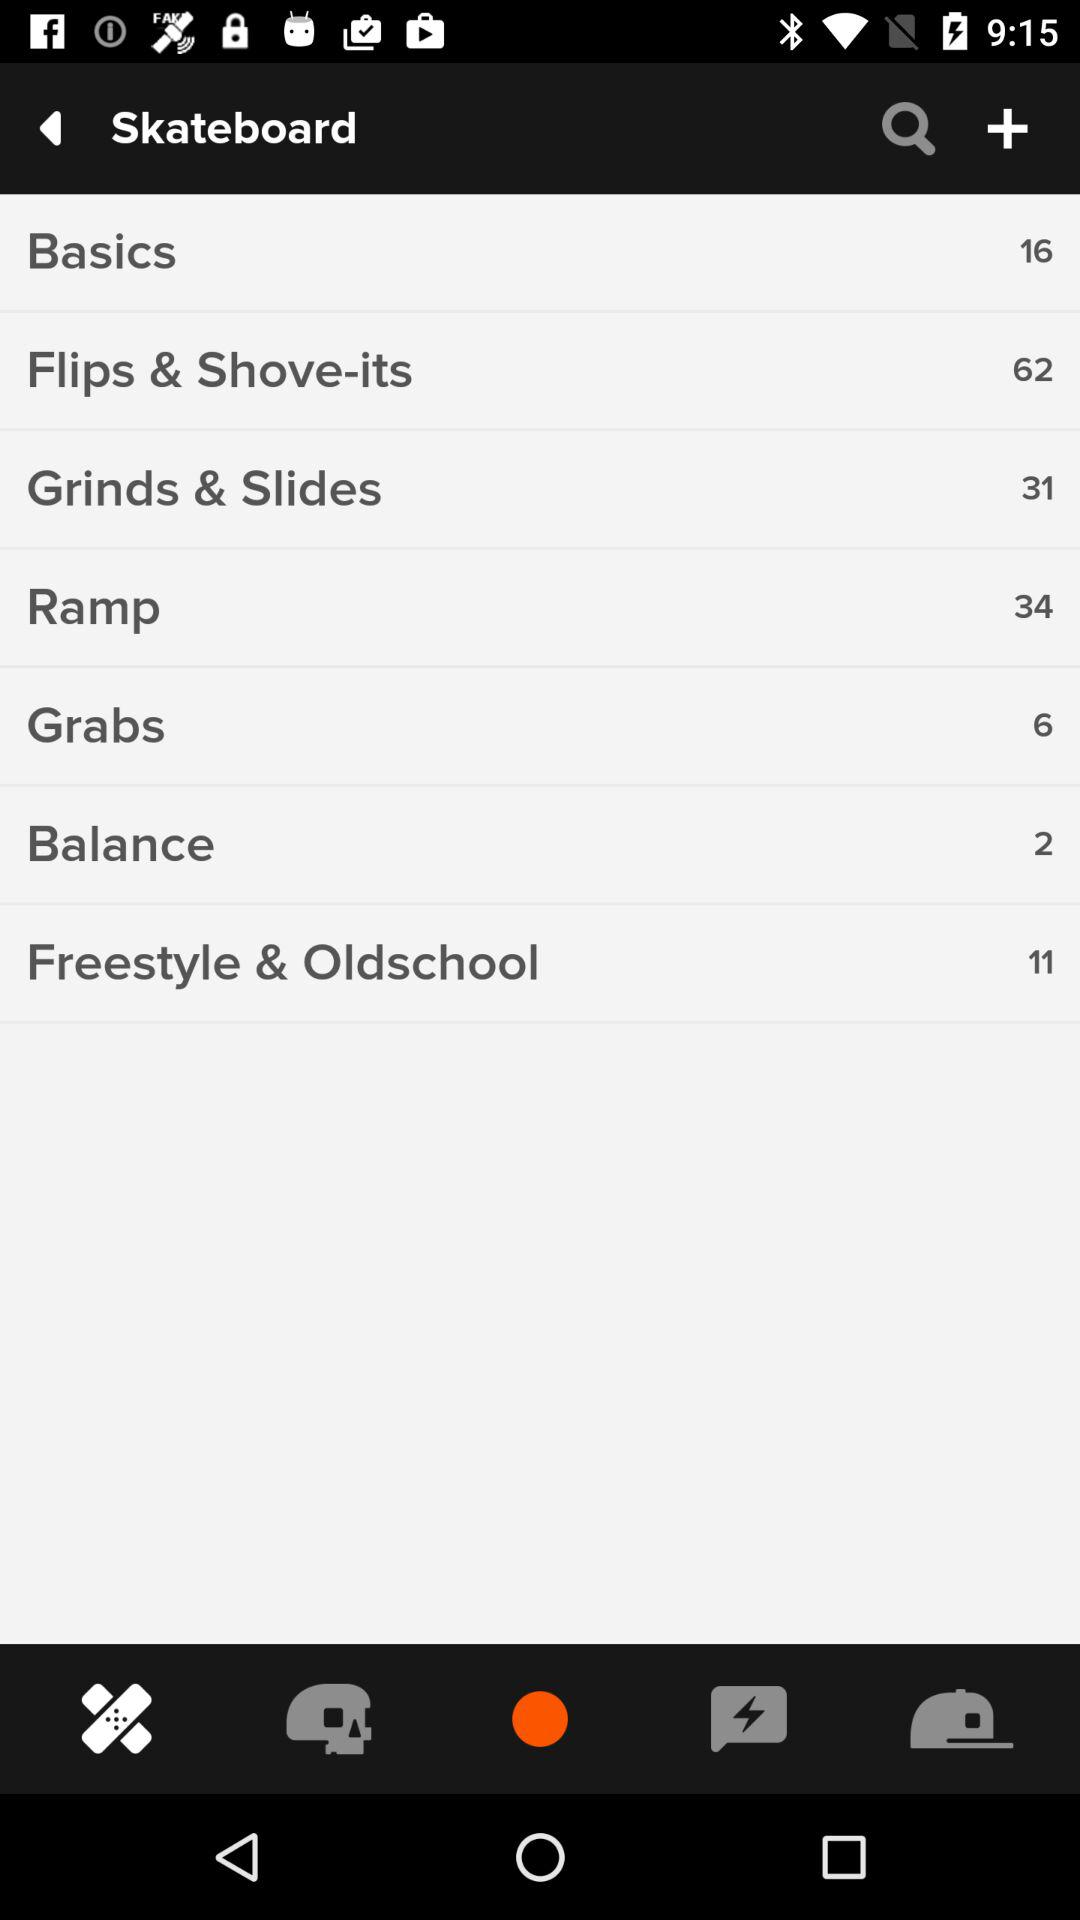How many "Balance" tricks are there on a skateboard? There are 2 "Balance" tricks. 